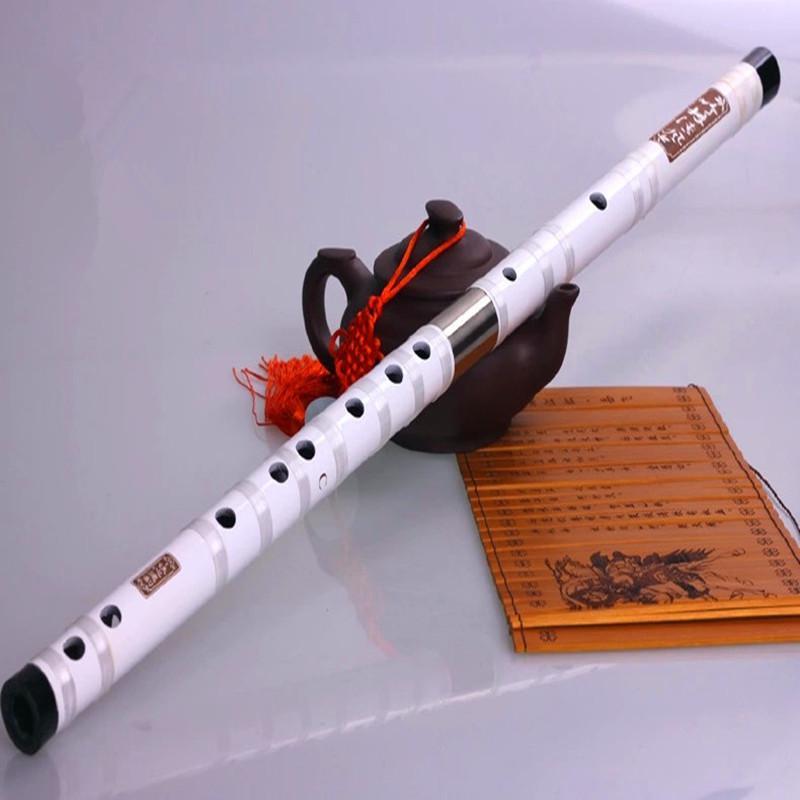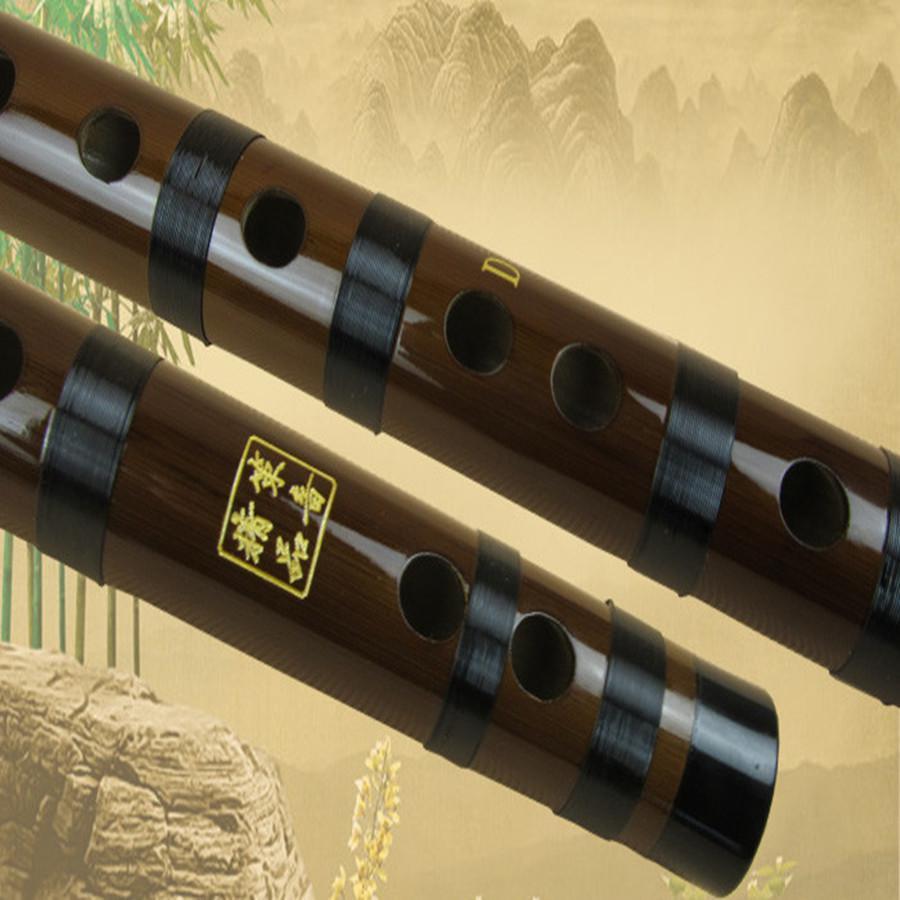The first image is the image on the left, the second image is the image on the right. For the images shown, is this caption "A human is touching a flute in one of the images." true? Answer yes or no. No. The first image is the image on the left, the second image is the image on the right. Examine the images to the left and right. Is the description "There are at least five futes." accurate? Answer yes or no. No. 